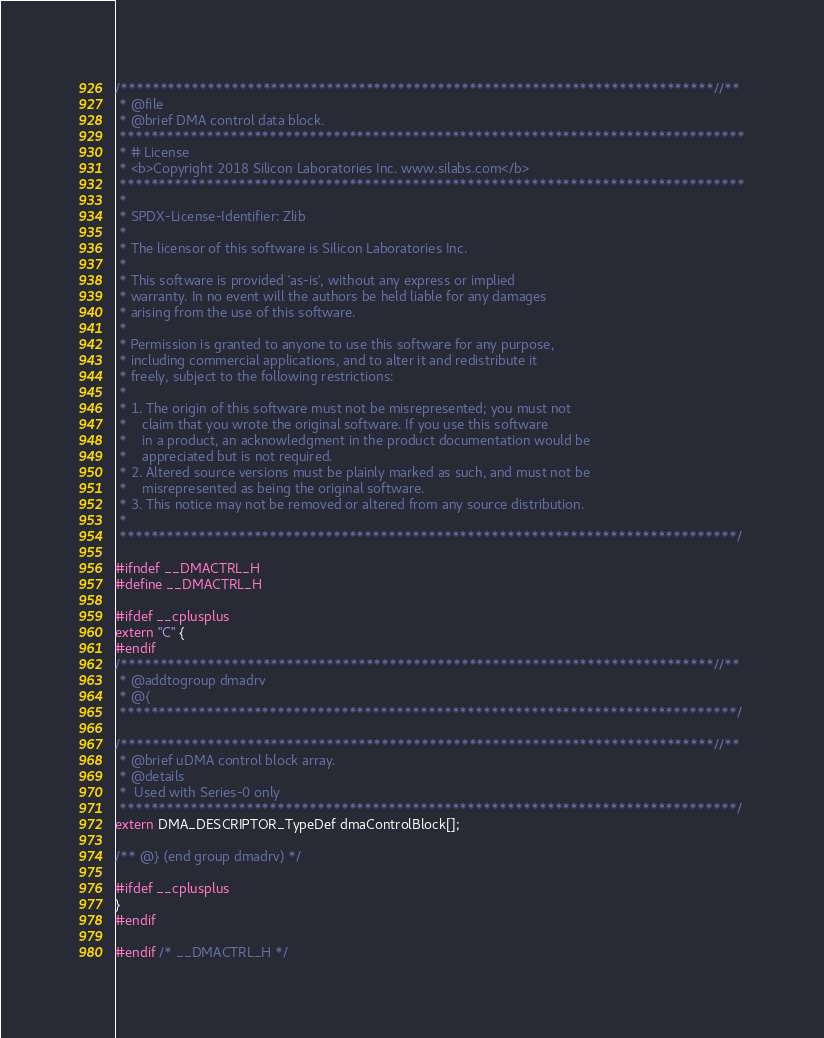Convert code to text. <code><loc_0><loc_0><loc_500><loc_500><_C_>/***************************************************************************//**
 * @file
 * @brief DMA control data block.
 *******************************************************************************
 * # License
 * <b>Copyright 2018 Silicon Laboratories Inc. www.silabs.com</b>
 *******************************************************************************
 *
 * SPDX-License-Identifier: Zlib
 *
 * The licensor of this software is Silicon Laboratories Inc.
 *
 * This software is provided 'as-is', without any express or implied
 * warranty. In no event will the authors be held liable for any damages
 * arising from the use of this software.
 *
 * Permission is granted to anyone to use this software for any purpose,
 * including commercial applications, and to alter it and redistribute it
 * freely, subject to the following restrictions:
 *
 * 1. The origin of this software must not be misrepresented; you must not
 *    claim that you wrote the original software. If you use this software
 *    in a product, an acknowledgment in the product documentation would be
 *    appreciated but is not required.
 * 2. Altered source versions must be plainly marked as such, and must not be
 *    misrepresented as being the original software.
 * 3. This notice may not be removed or altered from any source distribution.
 *
 ******************************************************************************/

#ifndef __DMACTRL_H
#define __DMACTRL_H

#ifdef __cplusplus
extern "C" {
#endif
/***************************************************************************//**
 * @addtogroup dmadrv
 * @{
 ******************************************************************************/

/***************************************************************************//**
 * @brief uDMA control block array.
 * @details
 *  Used with Series-0 only
 ******************************************************************************/
extern DMA_DESCRIPTOR_TypeDef dmaControlBlock[];

/** @} (end group dmadrv) */

#ifdef __cplusplus
}
#endif

#endif /* __DMACTRL_H */
</code> 